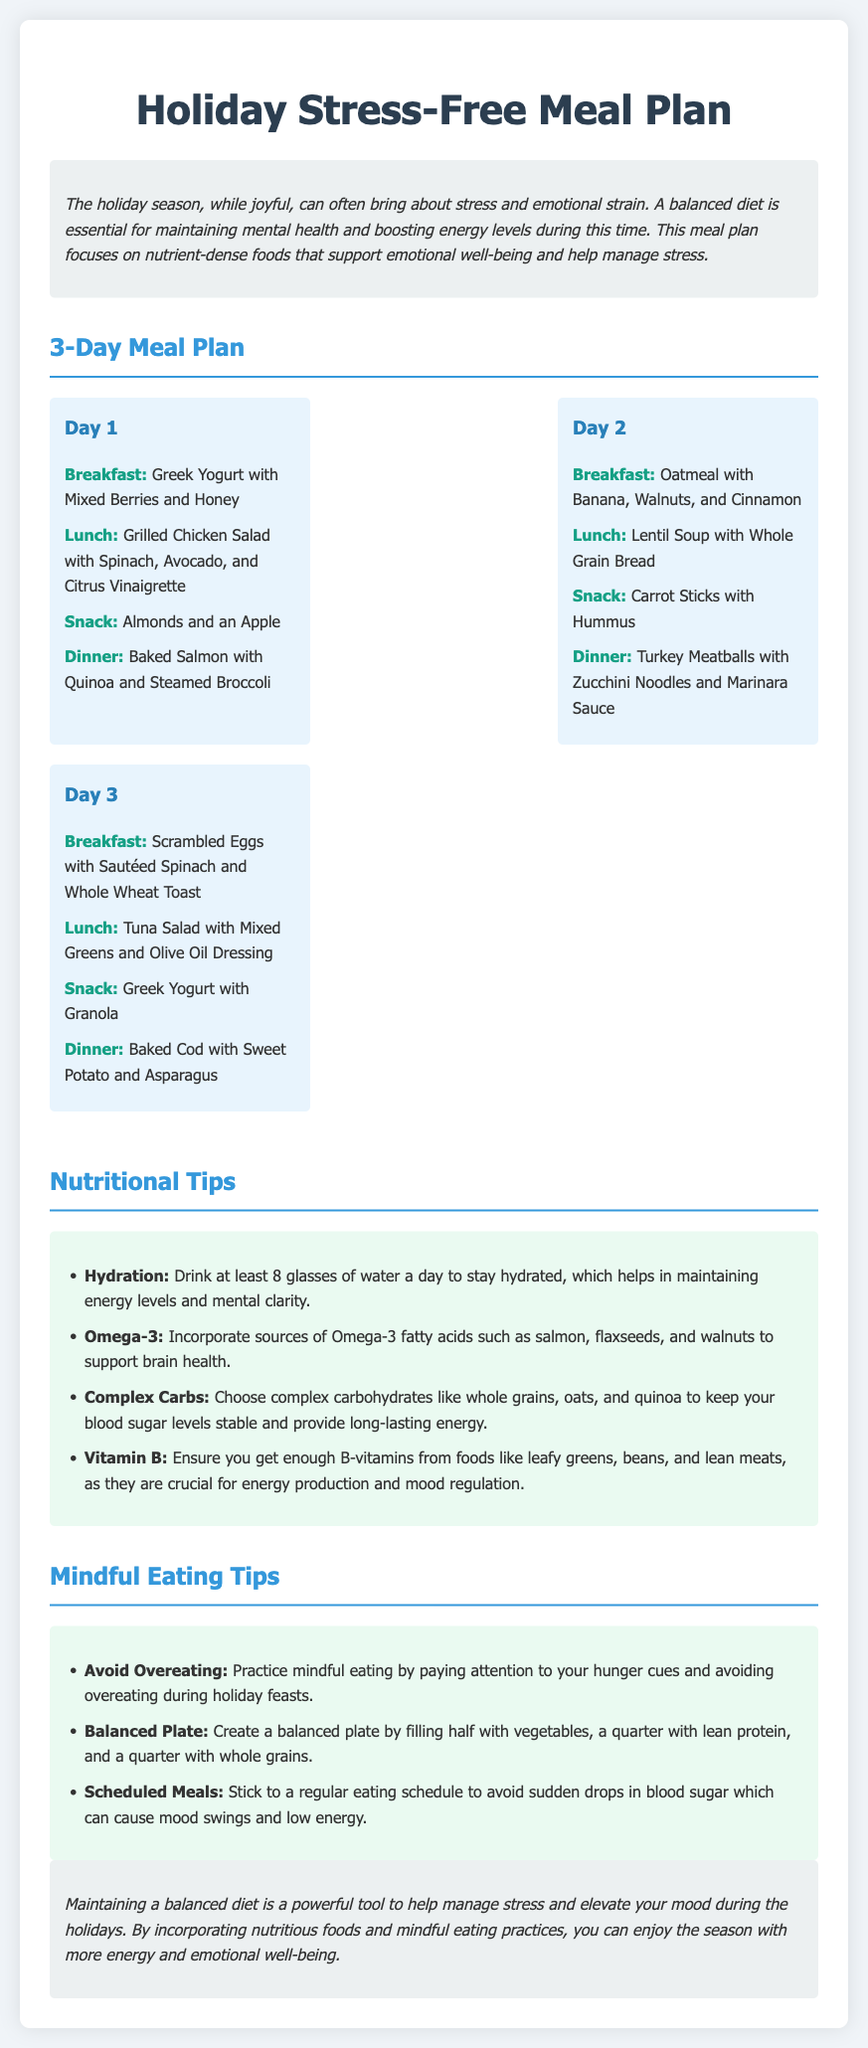What is the main focus of the meal plan? The meal plan focuses on nutrient-dense foods that support emotional well-being and help manage stress during the holiday season.
Answer: Nutrient-dense foods How many days does the meal plan cover? The document specifies a meal plan for three days.
Answer: 3 days What is included in the breakfast of Day 1? The breakfast for Day 1 is Greek Yogurt with Mixed Berries and Honey.
Answer: Greek Yogurt with Mixed Berries and Honey What should you drink at least to stay hydrated? The document suggests drinking at least 8 glasses of water a day to stay hydrated.
Answer: 8 glasses of water What are two foods mentioned that are sources of Omega-3 fatty acids? The document mentions salmon and walnuts as sources of Omega-3.
Answer: Salmon, walnuts Which meal type is served for lunch on Day 2? The lunch for Day 2 consists of Lentil Soup with Whole Grain Bread.
Answer: Lentil Soup with Whole Grain Bread What is a recommended practice to avoid during holiday feasts? The document advises to practice mindful eating to avoid overeating during holiday feasts.
Answer: Overeating How should a balanced plate be created according to the meal plan? A balanced plate should be filled half with vegetables, a quarter with lean protein, and a quarter with whole grains.
Answer: Half vegetables, quarter lean protein, quarter whole grains 